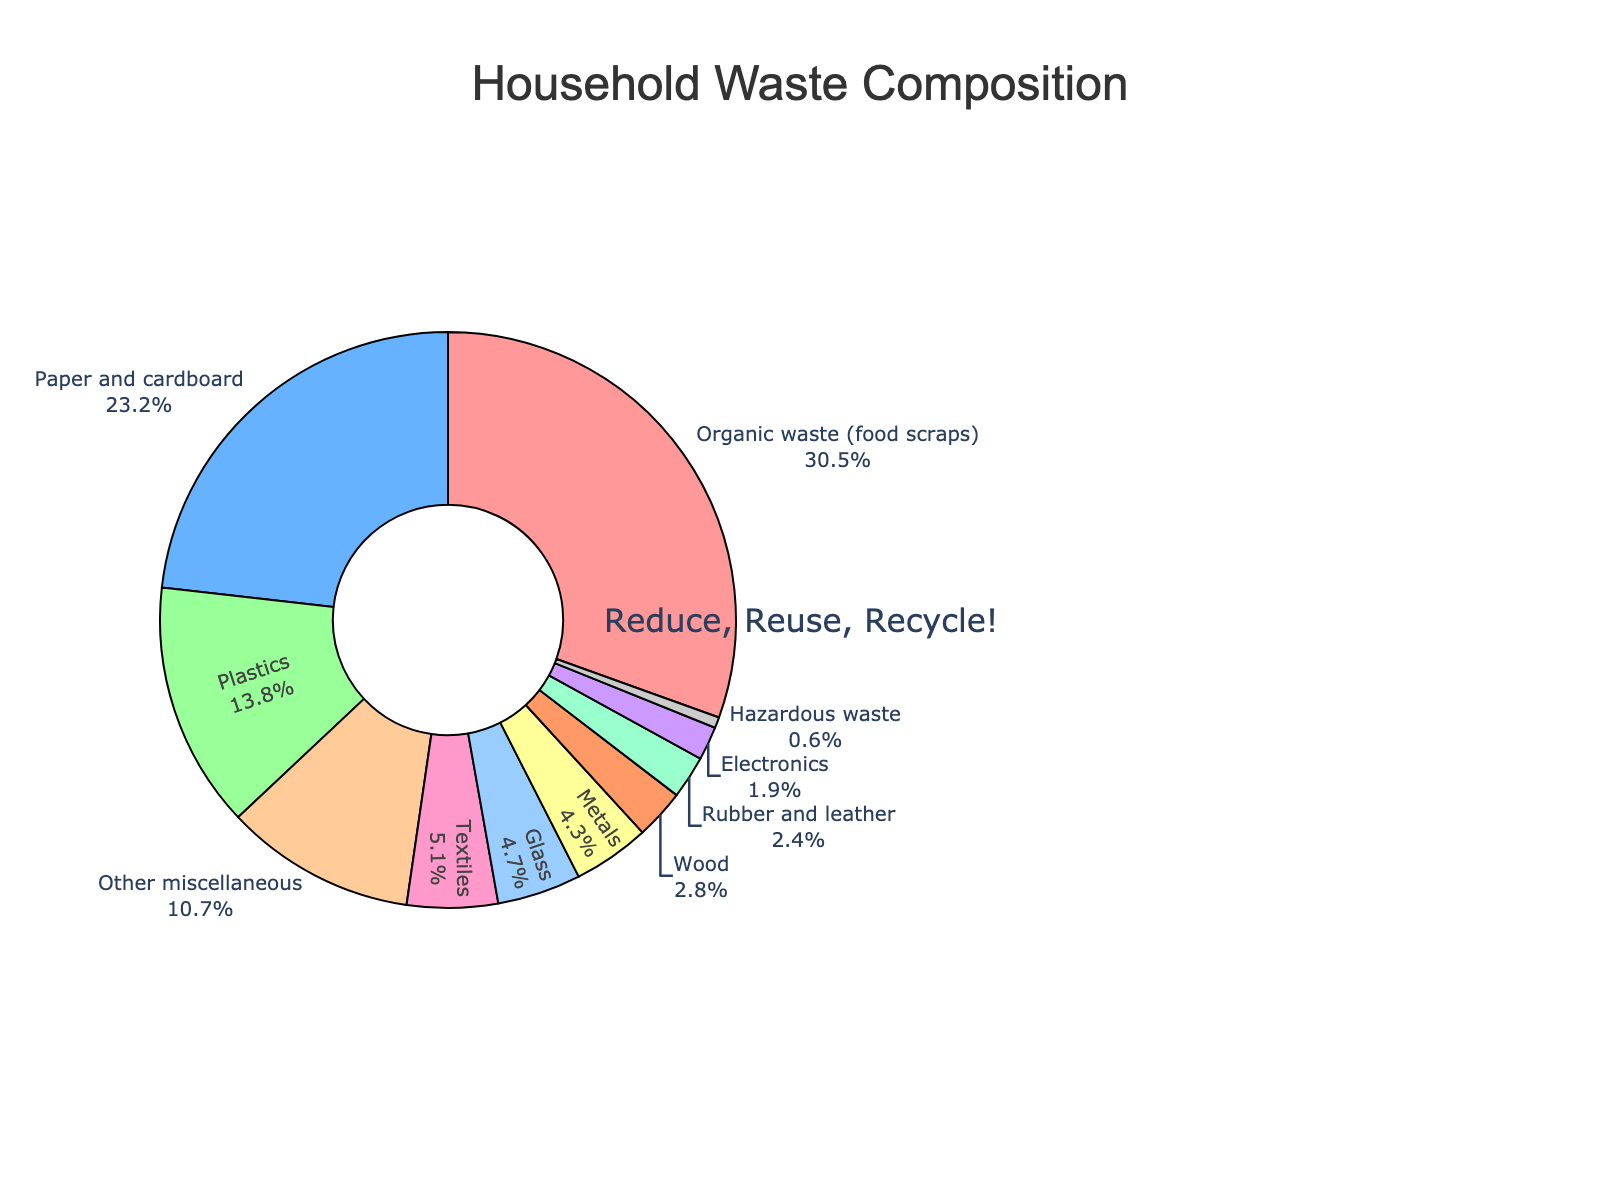What's the most common type of household waste? By looking at the figure, the largest segment is for "Organic waste (food scraps)" with a percentage of 30.5%, indicating it's the most common type
Answer: Organic waste (food scraps) Which two categories of waste are the least common? The smallest segments in the pie chart are "Hazardous waste" (0.6%) and "Electronics" (1.9%)
Answer: Hazardous waste and Electronics Are plastics or metals more prevalent in household waste? The segment for plastics (13.8%) is larger than the segment for metals (4.3%), indicating plastics are more prevalent
Answer: Plastics How much of the household waste is composed of organic waste and paper/cardboard combined? Adding the percentages of "Organic waste (food scraps)" (30.5%) and "Paper and cardboard" (23.2%) gives a total of 53.7%
Answer: 53.7% What is the difference in percentage between plastics and textiles? Subtracting the percentage of textiles (5.1%) from plastics (13.8%) results in a difference of 8.7%
Answer: 8.7% Which category is visually represented by a light blue color? By observing the color of the segments, the light blue corresponds to "Paper and cardboard"
Answer: Paper and cardboard What percentage of household waste does glass contribute? The segment for "Glass" shows a percentage of 4.7%
Answer: 4.7% Is the proportion of wood waste greater than rubber and leather waste? The segment for wood waste (2.8%) is larger than that for rubber and leather (2.4%)
Answer: Yes Which categories make up less than 5% each of the total household waste? The segments with percentages less than 5% are "Glass" (4.7%), "Metals" (4.3%), "Wood" (2.8%), "Rubber and leather" (2.4%), "Electronics" (1.9%), and "Hazardous waste" (0.6%)
Answer: Glass, Metals, Wood, Rubber and leather, Electronics, Hazardous waste What is the combined percentage of hazardous waste and other miscellaneous waste? Adding the percentages of "Hazardous waste" (0.6%) and "Other miscellaneous" (10.7%) results in a total of 11.3%
Answer: 11.3% 